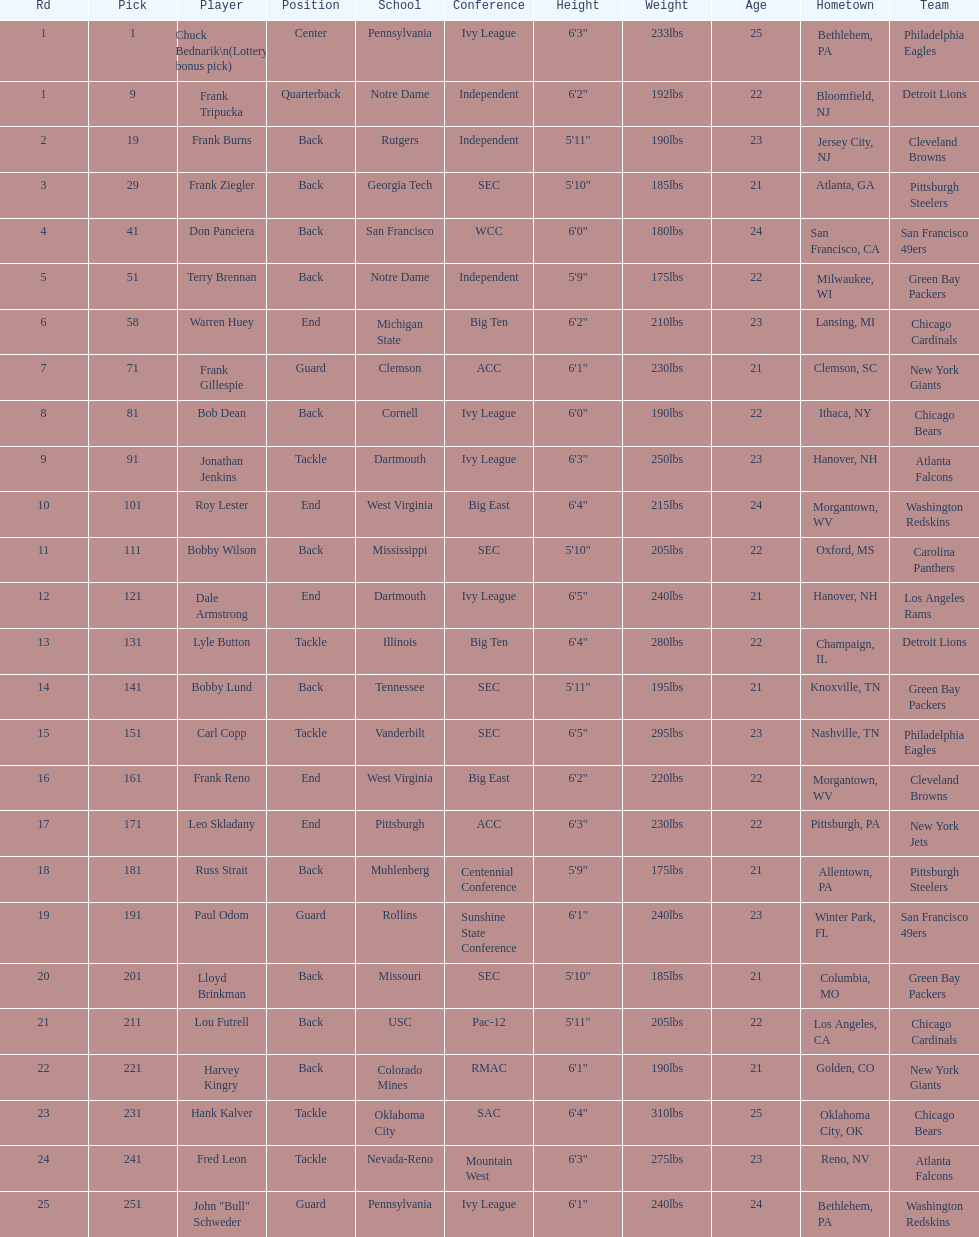What was the position that most of the players had? Back. 